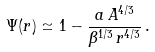<formula> <loc_0><loc_0><loc_500><loc_500>\Psi ( r ) \simeq 1 - \frac { a \, A ^ { 4 / 3 } } { \beta ^ { 1 / 3 } \, r ^ { 4 / 3 } } \, .</formula> 